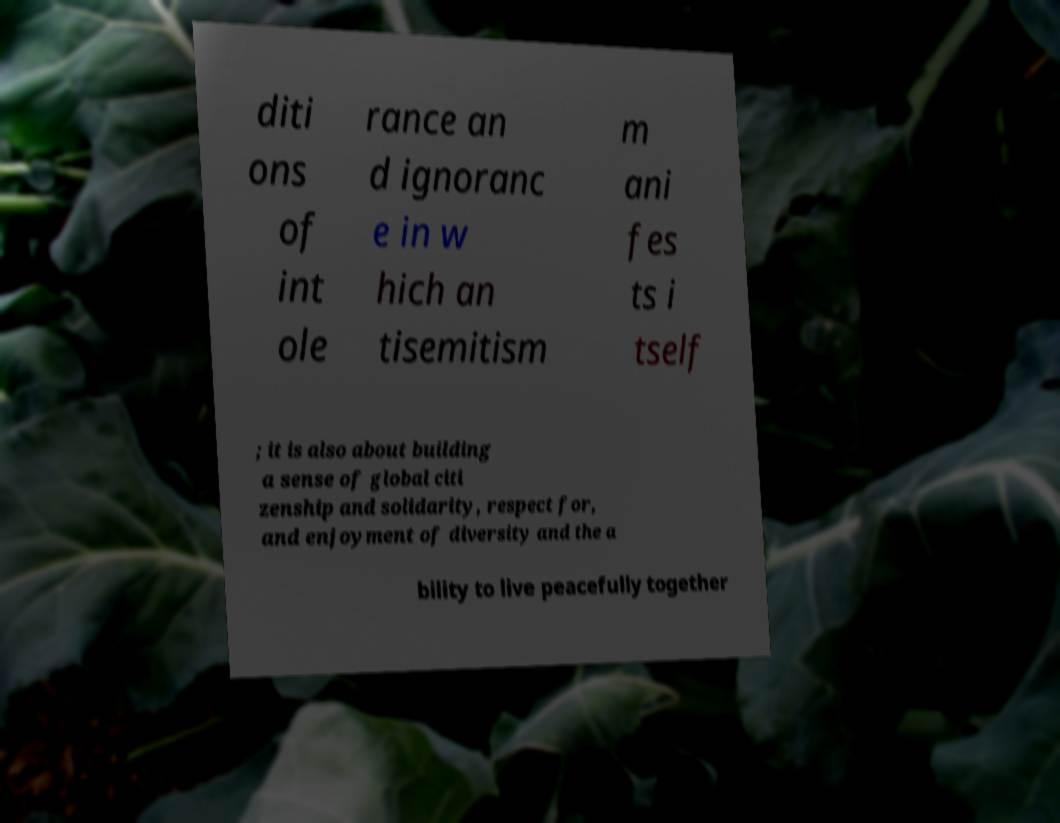Can you read and provide the text displayed in the image?This photo seems to have some interesting text. Can you extract and type it out for me? diti ons of int ole rance an d ignoranc e in w hich an tisemitism m ani fes ts i tself ; it is also about building a sense of global citi zenship and solidarity, respect for, and enjoyment of diversity and the a bility to live peacefully together 